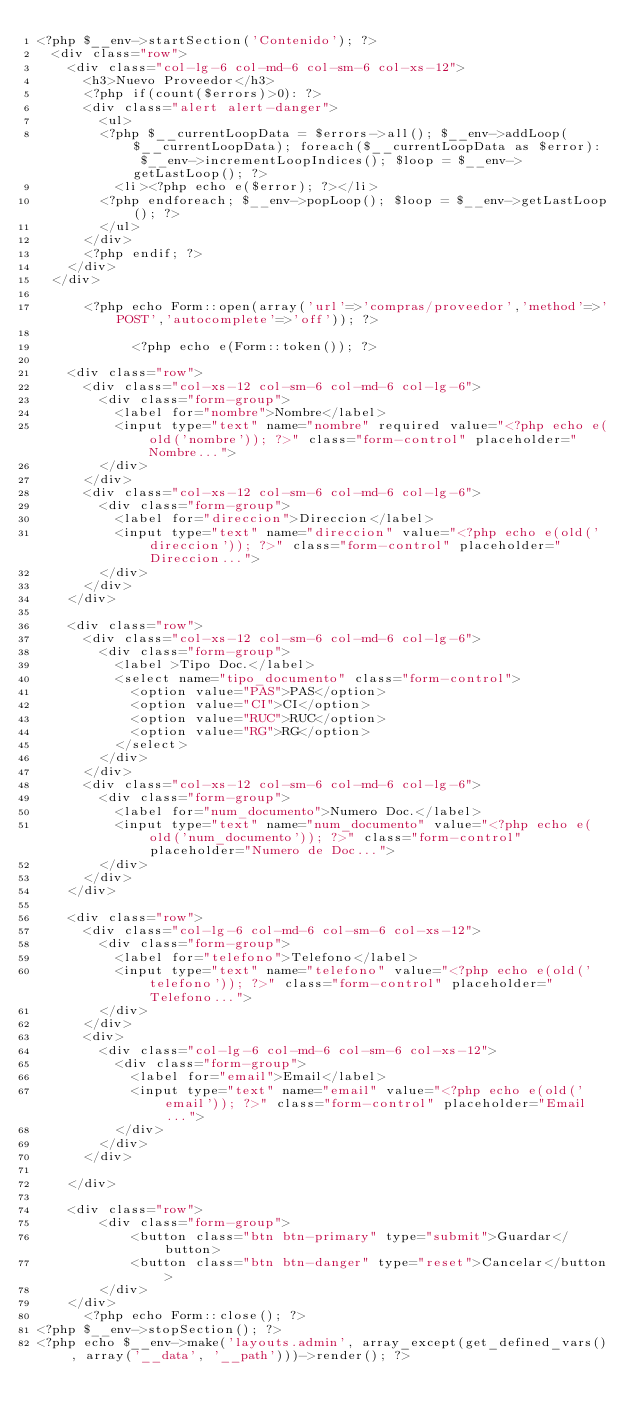<code> <loc_0><loc_0><loc_500><loc_500><_PHP_><?php $__env->startSection('Contenido'); ?>
	<div class="row">
		<div class="col-lg-6 col-md-6 col-sm-6 col-xs-12">
			<h3>Nuevo Proveedor</h3>
			<?php if(count($errors)>0): ?>
			<div class="alert alert-danger">
				<ul>
				<?php $__currentLoopData = $errors->all(); $__env->addLoop($__currentLoopData); foreach($__currentLoopData as $error): $__env->incrementLoopIndices(); $loop = $__env->getLastLoop(); ?>
					<li><?php echo e($error); ?></li>
				<?php endforeach; $__env->popLoop(); $loop = $__env->getLastLoop(); ?>
				</ul>
			</div>
			<?php endif; ?>
		</div>
	</div>

			<?php echo Form::open(array('url'=>'compras/proveedor','method'=>'POST','autocomplete'=>'off')); ?>

            <?php echo e(Form::token()); ?>

    <div class="row">
    	<div class="col-xs-12 col-sm-6 col-md-6 col-lg-6">
    		<div class="form-group">
    			<label for="nombre">Nombre</label>
    			<input type="text" name="nombre" required value="<?php echo e(old('nombre')); ?>" class="form-control" placeholder="Nombre...">
    		</div>
    	</div>
    	<div class="col-xs-12 col-sm-6 col-md-6 col-lg-6">
    		<div class="form-group">
    			<label for="direccion">Direccion</label>
    			<input type="text" name="direccion" value="<?php echo e(old('direccion')); ?>" class="form-control" placeholder="Direccion...">
    		</div>
    	</div>
    </div>

    <div class="row">
    	<div class="col-xs-12 col-sm-6 col-md-6 col-lg-6">
    		<div class="form-group">
    			<label >Tipo Doc.</label>
    			<select name="tipo_documento" class="form-control">
    				<option value="PAS">PAS</option>
    				<option value="CI">CI</option>
    				<option value="RUC">RUC</option>
    				<option value="RG">RG</option>
    			</select>
    		</div>
    	</div>
    	<div class="col-xs-12 col-sm-6 col-md-6 col-lg-6">
    		<div class="form-group">
    			<label for="num_documento">Numero Doc.</label>
    			<input type="text" name="num_documento" value="<?php echo e(old('num_documento')); ?>" class="form-control" placeholder="Numero de Doc...">   			
    		</div>
    	</div>
    </div>

    <div class="row">
    	<div class="col-lg-6 col-md-6 col-sm-6 col-xs-12">
    		<div class="form-group">
    			<label for="telefono">Telefono</label>
    			<input type="text" name="telefono" value="<?php echo e(old('telefono')); ?>" class="form-control" placeholder="Telefono...">
    		</div>
    	</div>
    	<div>
    		<div class="col-lg-6 col-md-6 col-sm-6 col-xs-12">
    			<div class="form-group">
    				<label for="email">Email</label>
    				<input type="text" name="email" value="<?php echo e(old('email')); ?>" class="form-control" placeholder="Email...">
    			</div>
    		</div>
    	</div>
    	
    </div>

    <div class="row">
        <div class="form-group">
            <button class="btn btn-primary" type="submit">Guardar</button>
            <button class="btn btn-danger" type="reset">Cancelar</button>
        </div>
    </div>
			<?php echo Form::close(); ?>		 
<?php $__env->stopSection(); ?>
<?php echo $__env->make('layouts.admin', array_except(get_defined_vars(), array('__data', '__path')))->render(); ?></code> 